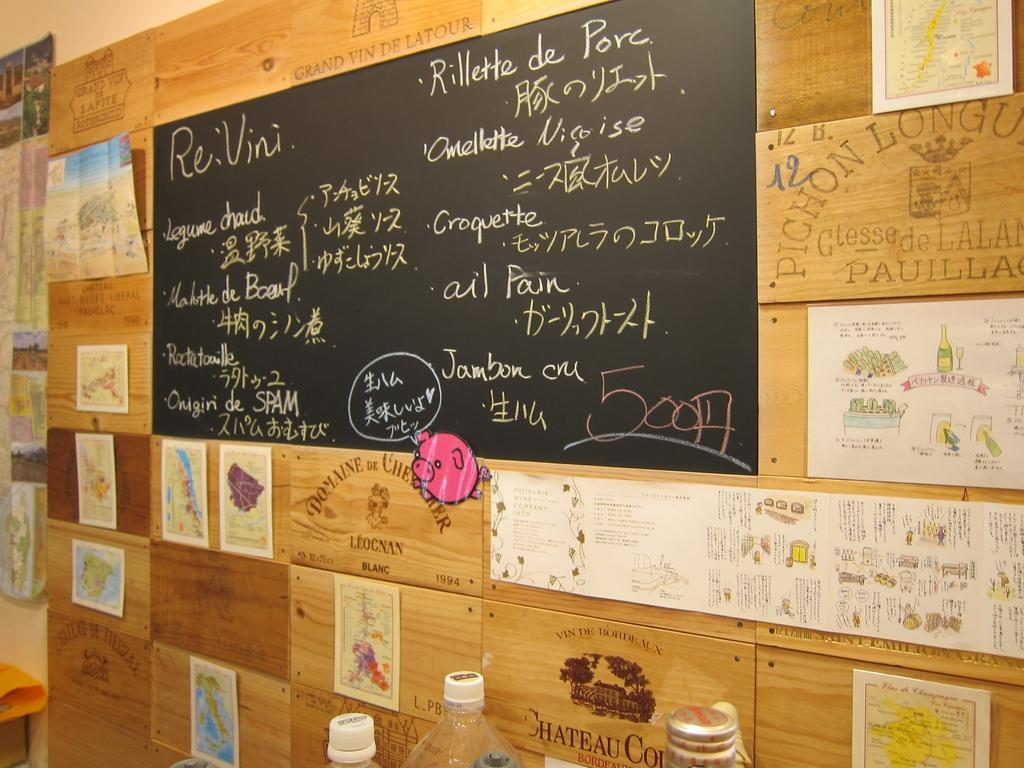Provide a one-sentence caption for the provided image. A menu board with food including Omellette on it. 